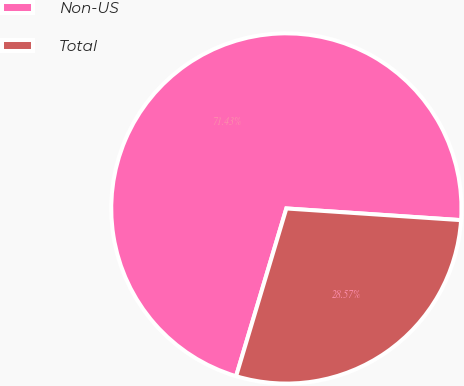<chart> <loc_0><loc_0><loc_500><loc_500><pie_chart><fcel>Non-US<fcel>Total<nl><fcel>71.43%<fcel>28.57%<nl></chart> 